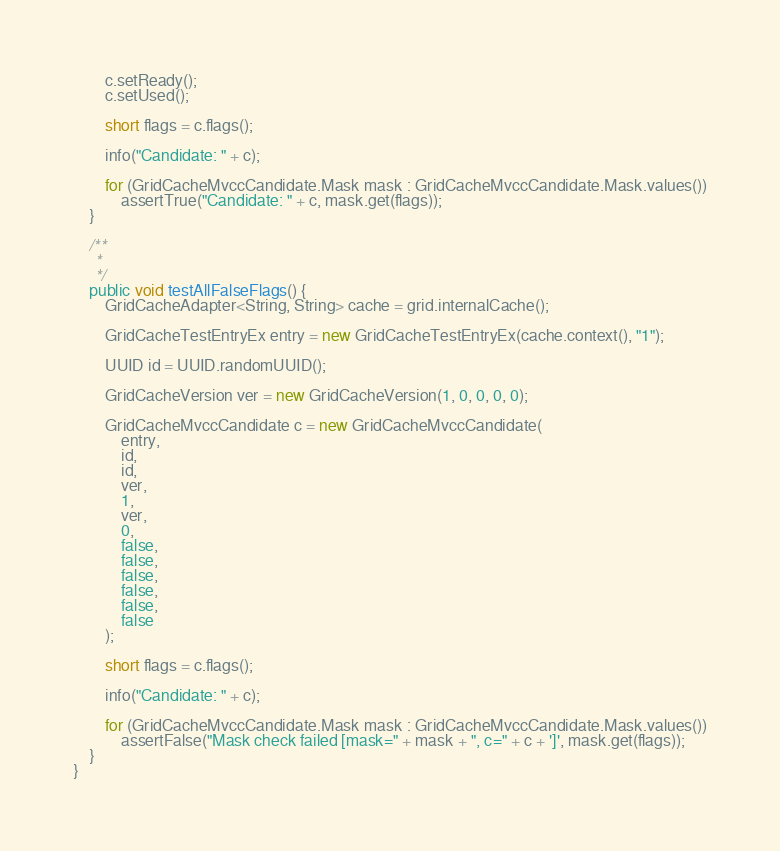<code> <loc_0><loc_0><loc_500><loc_500><_Java_>        c.setReady();
        c.setUsed();

        short flags = c.flags();

        info("Candidate: " + c);

        for (GridCacheMvccCandidate.Mask mask : GridCacheMvccCandidate.Mask.values())
            assertTrue("Candidate: " + c, mask.get(flags));
    }

    /**
     *
     */
    public void testAllFalseFlags() {
        GridCacheAdapter<String, String> cache = grid.internalCache();

        GridCacheTestEntryEx entry = new GridCacheTestEntryEx(cache.context(), "1");

        UUID id = UUID.randomUUID();

        GridCacheVersion ver = new GridCacheVersion(1, 0, 0, 0, 0);

        GridCacheMvccCandidate c = new GridCacheMvccCandidate(
            entry,
            id,
            id,
            ver,
            1,
            ver,
            0,
            false,
            false,
            false,
            false,
            false,
            false
        );

        short flags = c.flags();

        info("Candidate: " + c);

        for (GridCacheMvccCandidate.Mask mask : GridCacheMvccCandidate.Mask.values())
            assertFalse("Mask check failed [mask=" + mask + ", c=" + c + ']', mask.get(flags));
    }
}</code> 